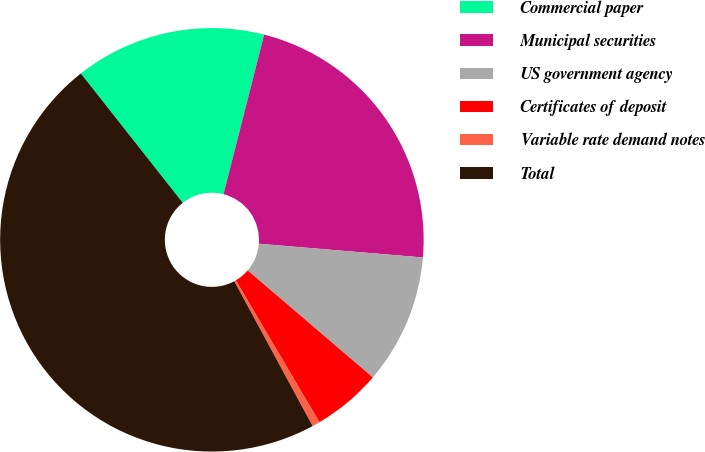Convert chart to OTSL. <chart><loc_0><loc_0><loc_500><loc_500><pie_chart><fcel>Commercial paper<fcel>Municipal securities<fcel>US government agency<fcel>Certificates of deposit<fcel>Variable rate demand notes<fcel>Total<nl><fcel>14.59%<fcel>22.36%<fcel>9.93%<fcel>5.26%<fcel>0.59%<fcel>47.27%<nl></chart> 